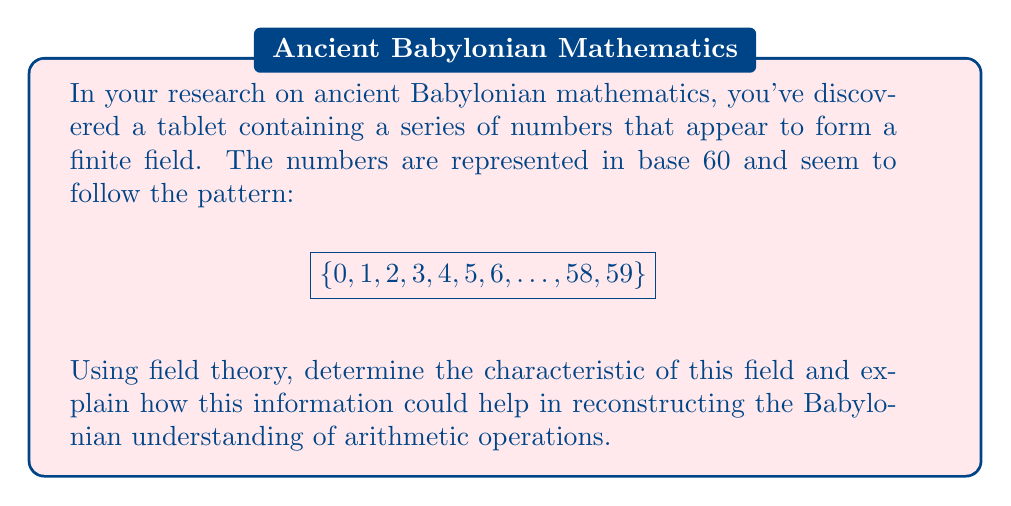Provide a solution to this math problem. To determine the characteristic of the field and understand its implications for Babylonian mathematics, we can follow these steps:

1) First, recall that the characteristic of a field is the smallest positive integer $n$ such that:

   $$\underbrace{1 + 1 + \ldots + 1}_{n \text{ times}} = 0$$

   If no such $n$ exists, the characteristic is 0.

2) In this case, we see that the field contains 60 elements. In a finite field, the number of elements is always a power of a prime. 60 is not a prime power, so this cannot be the entire field.

3) The actual field must be a subfield of this set of numbers. The largest possible subfield would have $p$ elements, where $p$ is the largest prime factor of 60.

4) The prime factorization of 60 is $2^2 \times 3 \times 5$. The largest prime factor is 5.

5) Therefore, the characteristic of this field is 5.

6) This means that in the Babylonian system represented by this field:

   $$1 + 1 + 1 + 1 + 1 \equiv 0 \pmod{5}$$

7) This information helps us reconstruct Babylonian arithmetic in several ways:
   - It suggests that Babylonians were aware of modular arithmetic, at least implicitly.
   - It indicates that their calculations might have involved reducing results modulo 5.
   - It provides insight into how they might have handled fractions and division, as inverse elements in this field would be calculated modulo 5.

8) The base-60 system they used (which is evident from the range of numbers 0-59) can be seen as an extension of this fundamental field of 5 elements, possibly indicating a sophisticated understanding of number theory.
Answer: 5 